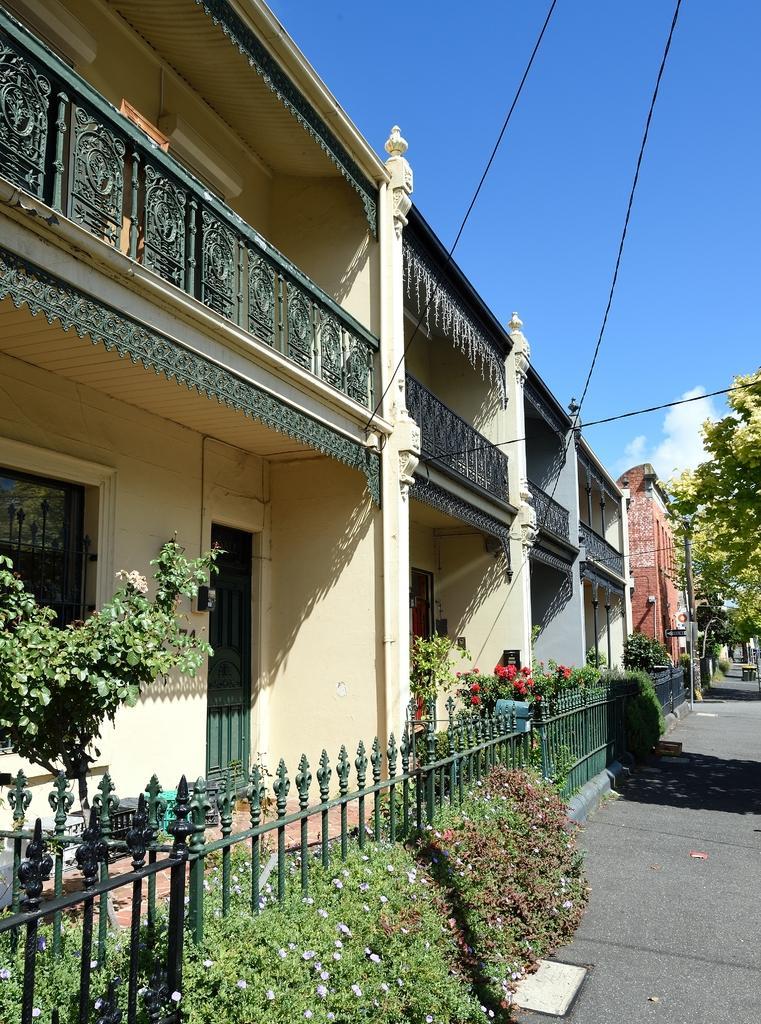How would you summarize this image in a sentence or two? In the image I can see a place where we have some houses and also I can see some trees, plants and also I can see some flowers. 